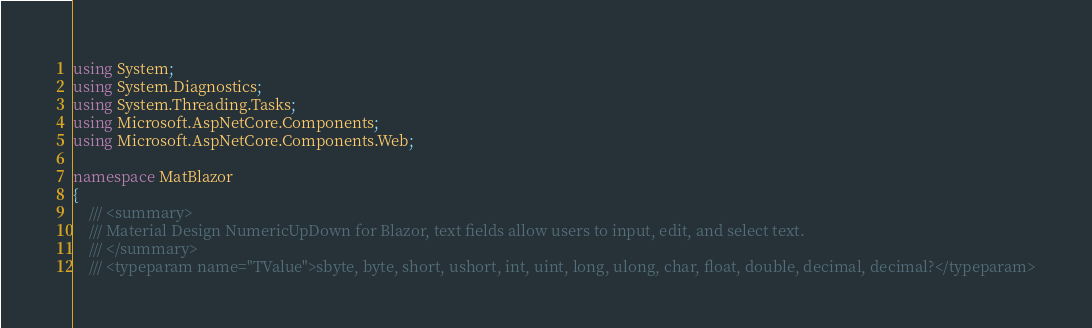<code> <loc_0><loc_0><loc_500><loc_500><_C#_>using System;
using System.Diagnostics;
using System.Threading.Tasks;
using Microsoft.AspNetCore.Components;
using Microsoft.AspNetCore.Components.Web;

namespace MatBlazor
{
    /// <summary>
    /// Material Design NumericUpDown for Blazor, text fields allow users to input, edit, and select text.
    /// </summary>
    /// <typeparam name="TValue">sbyte, byte, short, ushort, int, uint, long, ulong, char, float, double, decimal, decimal?</typeparam></code> 